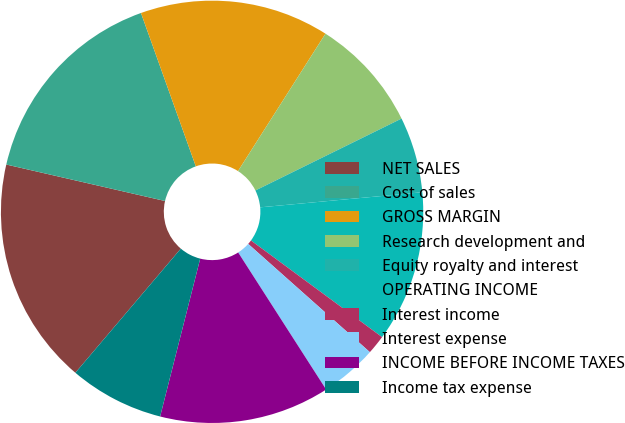Convert chart. <chart><loc_0><loc_0><loc_500><loc_500><pie_chart><fcel>NET SALES<fcel>Cost of sales<fcel>GROSS MARGIN<fcel>Research development and<fcel>Equity royalty and interest<fcel>OPERATING INCOME<fcel>Interest income<fcel>Interest expense<fcel>INCOME BEFORE INCOME TAXES<fcel>Income tax expense<nl><fcel>17.39%<fcel>15.94%<fcel>14.49%<fcel>8.7%<fcel>5.8%<fcel>11.59%<fcel>1.46%<fcel>4.35%<fcel>13.04%<fcel>7.25%<nl></chart> 